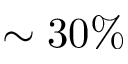Convert formula to latex. <formula><loc_0><loc_0><loc_500><loc_500>\sim 3 0 \%</formula> 